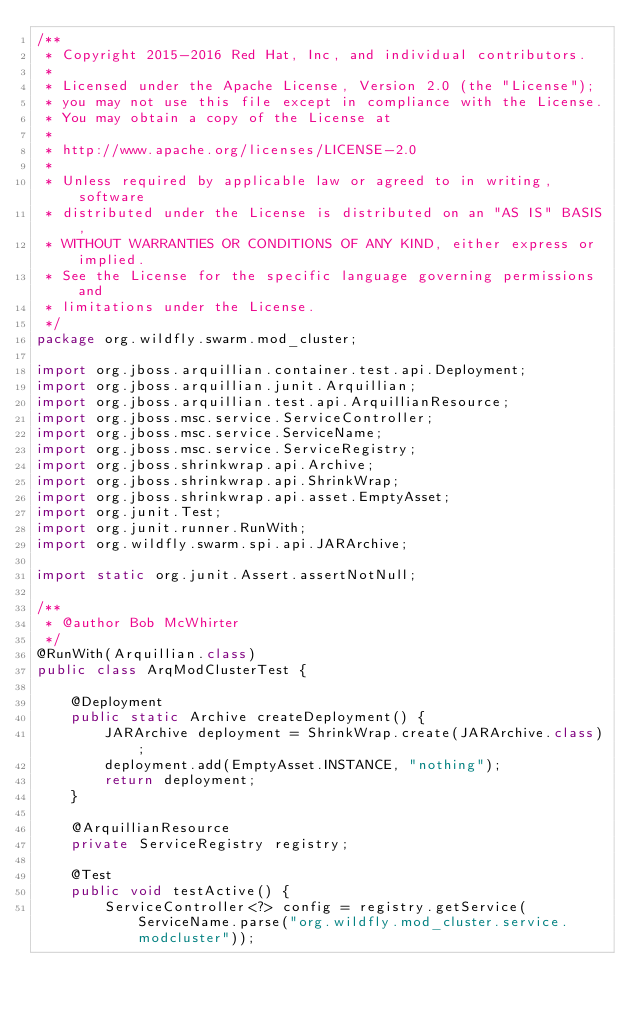<code> <loc_0><loc_0><loc_500><loc_500><_Java_>/**
 * Copyright 2015-2016 Red Hat, Inc, and individual contributors.
 *
 * Licensed under the Apache License, Version 2.0 (the "License");
 * you may not use this file except in compliance with the License.
 * You may obtain a copy of the License at
 *
 * http://www.apache.org/licenses/LICENSE-2.0
 *
 * Unless required by applicable law or agreed to in writing, software
 * distributed under the License is distributed on an "AS IS" BASIS,
 * WITHOUT WARRANTIES OR CONDITIONS OF ANY KIND, either express or implied.
 * See the License for the specific language governing permissions and
 * limitations under the License.
 */
package org.wildfly.swarm.mod_cluster;

import org.jboss.arquillian.container.test.api.Deployment;
import org.jboss.arquillian.junit.Arquillian;
import org.jboss.arquillian.test.api.ArquillianResource;
import org.jboss.msc.service.ServiceController;
import org.jboss.msc.service.ServiceName;
import org.jboss.msc.service.ServiceRegistry;
import org.jboss.shrinkwrap.api.Archive;
import org.jboss.shrinkwrap.api.ShrinkWrap;
import org.jboss.shrinkwrap.api.asset.EmptyAsset;
import org.junit.Test;
import org.junit.runner.RunWith;
import org.wildfly.swarm.spi.api.JARArchive;

import static org.junit.Assert.assertNotNull;

/**
 * @author Bob McWhirter
 */
@RunWith(Arquillian.class)
public class ArqModClusterTest {

    @Deployment
    public static Archive createDeployment() {
        JARArchive deployment = ShrinkWrap.create(JARArchive.class);
        deployment.add(EmptyAsset.INSTANCE, "nothing");
        return deployment;
    }

    @ArquillianResource
    private ServiceRegistry registry;

    @Test
    public void testActive() {
        ServiceController<?> config = registry.getService(ServiceName.parse("org.wildfly.mod_cluster.service.modcluster"));</code> 